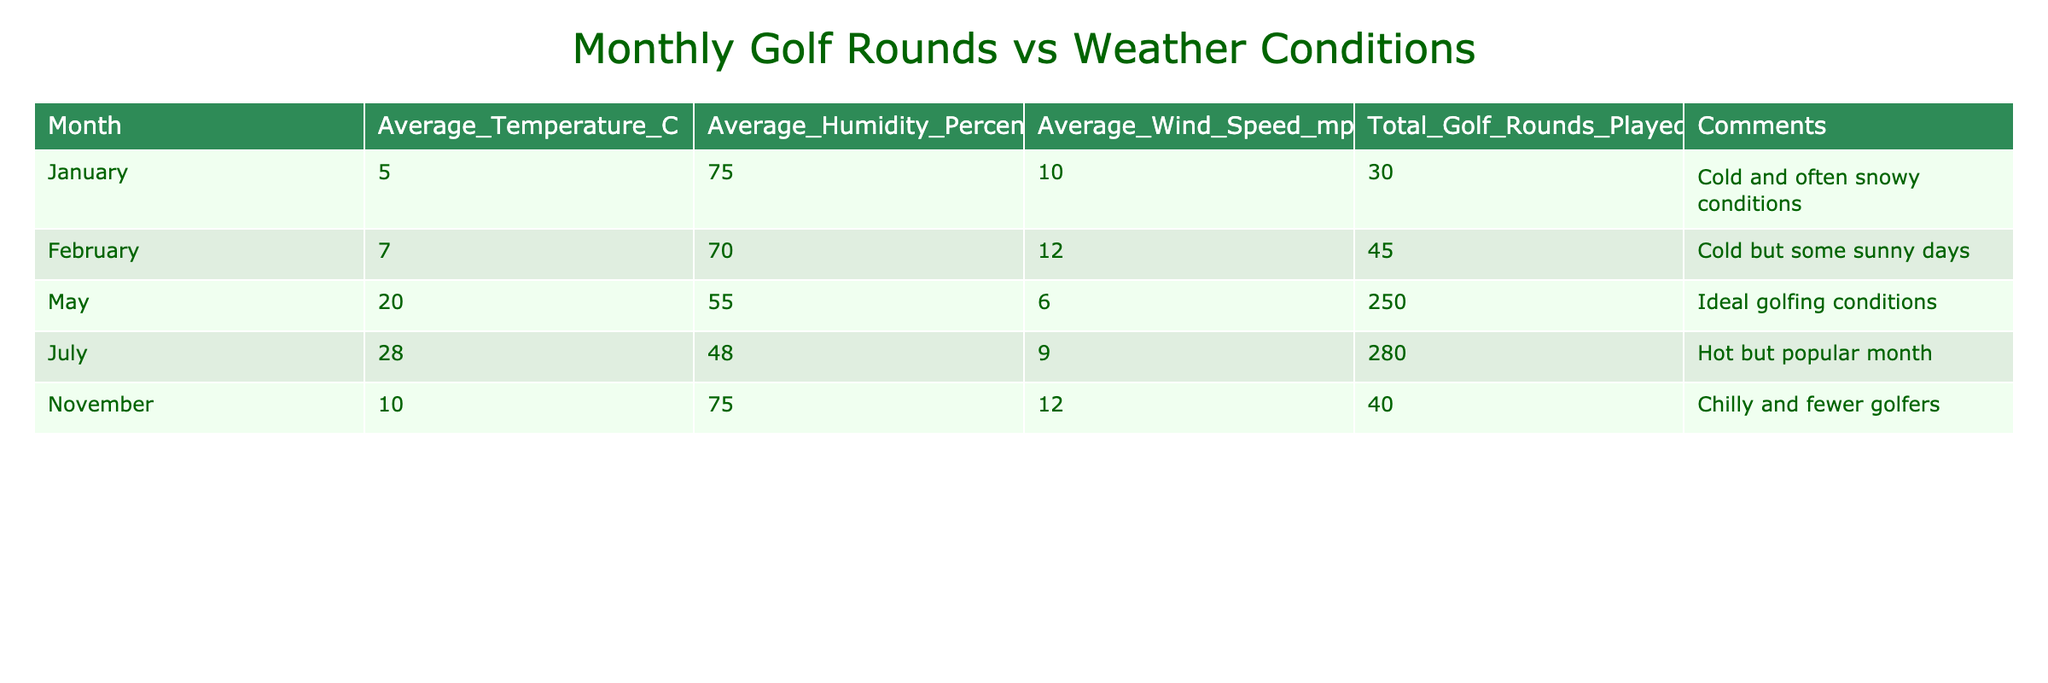What month had the highest total golf rounds played? The row for July shows the highest total golf rounds played with a value of 280.
Answer: July What is the average temperature in November? The temperature for November is directly listed in the table as 10 degrees Celsius.
Answer: 10 How many total golf rounds were played in the months of May and July? The total golf rounds for May is 250 and for July is 280. Adding these gives 250 + 280 = 530.
Answer: 530 Was the average humidity percentage highest in July? The average humidity for July is 48%, which is lower than November's average of 75%, thus the statement is false.
Answer: No What is the difference in total golf rounds played between January and February? The total golf rounds for January is 30 and for February is 45. The difference is calculated as 45 - 30 = 15.
Answer: 15 What is the average wind speed across all months listed? The average wind speed can be calculated by adding 10 + 12 + 6 + 9 + 12 = 49 and dividing by 5 (the number of months), which results in 49 / 5 = 9.8 mph.
Answer: 9.8 Which month experienced ideal golfing conditions based on comments? The table's comments indicate May has "Ideal golfing conditions."
Answer: May Did any month report a decrease in total golf rounds from one month to the next? Observing the values: January to February increases (30 to 45), February to May increases (45 to 250), May to July increases (250 to 280), July to November decreases (280 to 40). Thus, yes, there was a decrease in rounds from July to November.
Answer: Yes What is the average humidity percentage for the months with the highest total golf rounds played? Only May and July qualify (total golf rounds 250 and 280), with humidity 55% and 48%, respectively. The average is (55 + 48) / 2 = 51.5%.
Answer: 51.5 